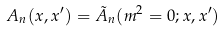<formula> <loc_0><loc_0><loc_500><loc_500>A _ { n } ( x , x ^ { \prime } ) = { \tilde { A } } _ { n } ( m ^ { 2 } = 0 ; x , x ^ { \prime } )</formula> 